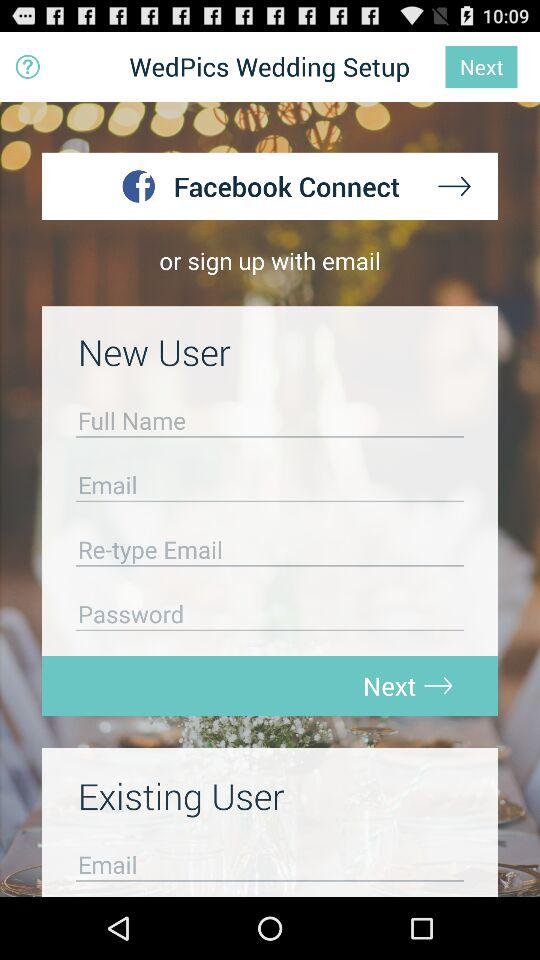What are the different options available for signing up? The different available options are "Facebook" and "email". 